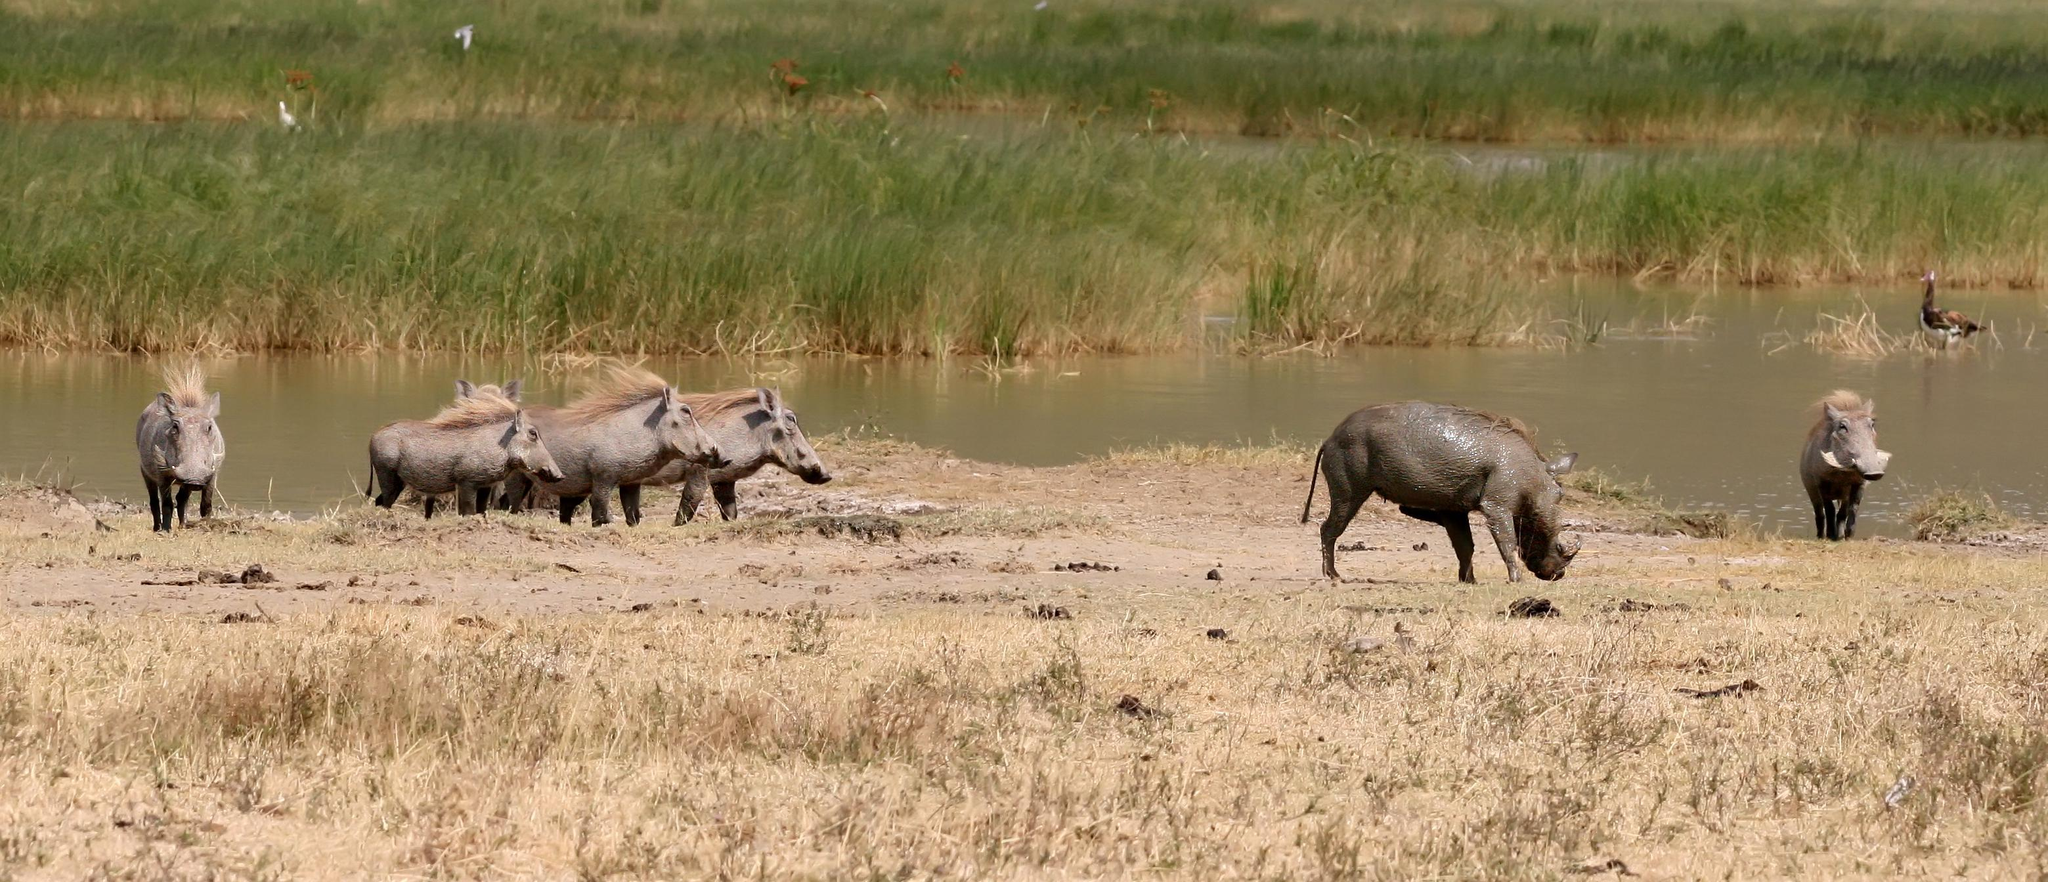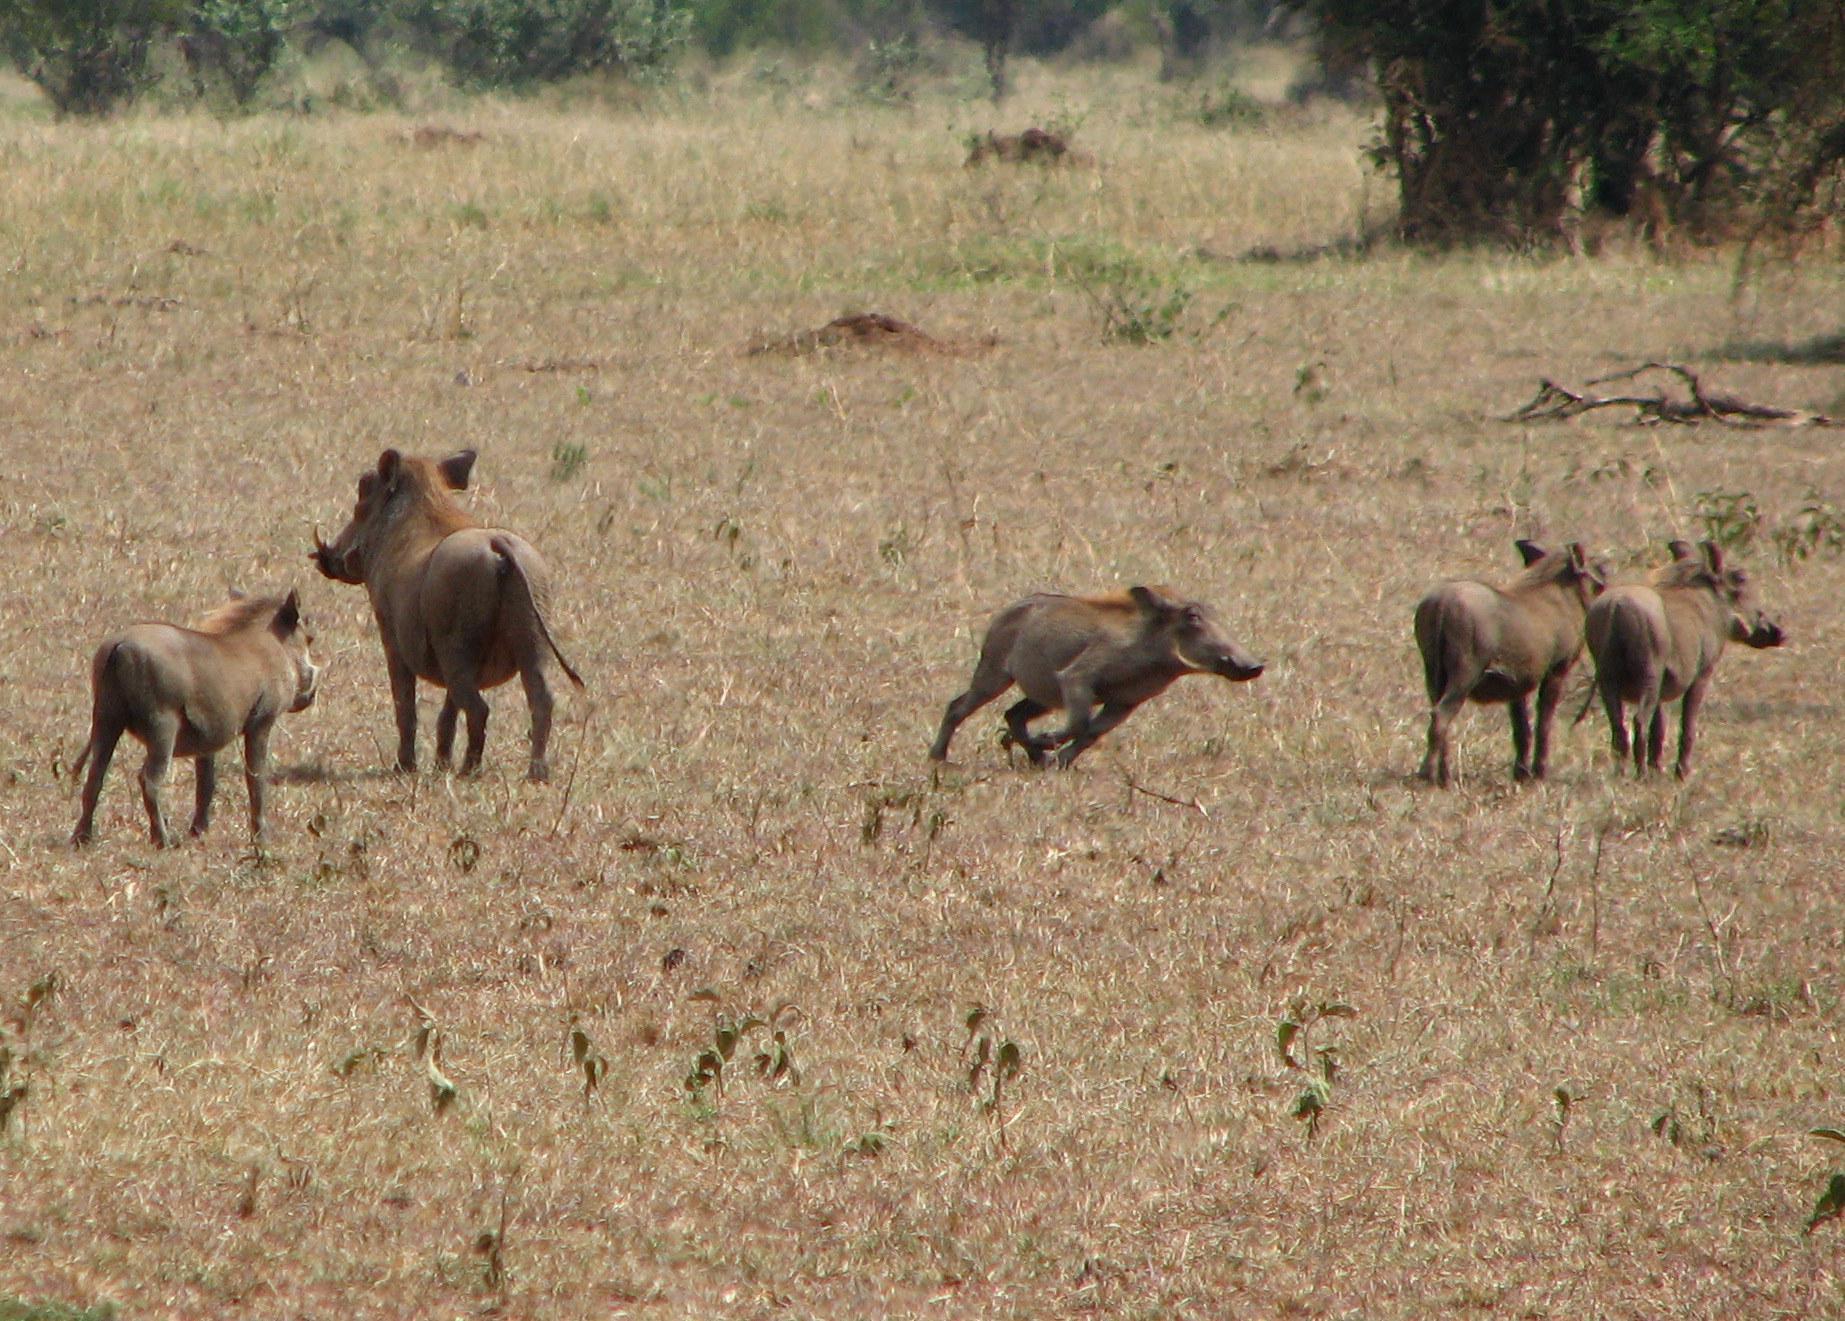The first image is the image on the left, the second image is the image on the right. Examine the images to the left and right. Is the description "One image contains no more than three animals." accurate? Answer yes or no. No. 